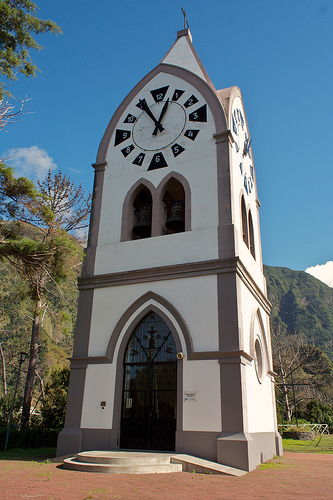What time is shown on the clock? The clock shows a time of approximately 9:25. Why might the clock tower be significant in this area? The clock tower might be significant as a historical landmark, a navigational point within the town, or as a central feature in the area used for communal activities and gatherings. Imagine the tower at night. What might it look like? At night, the tower might be illuminated by soft lights, casting shadows that highlight its architectural details. The clock face could glow, making it visible from afar. The surrounding area might be quieter, with the occasional sound of the bell echoing in the stillness. 